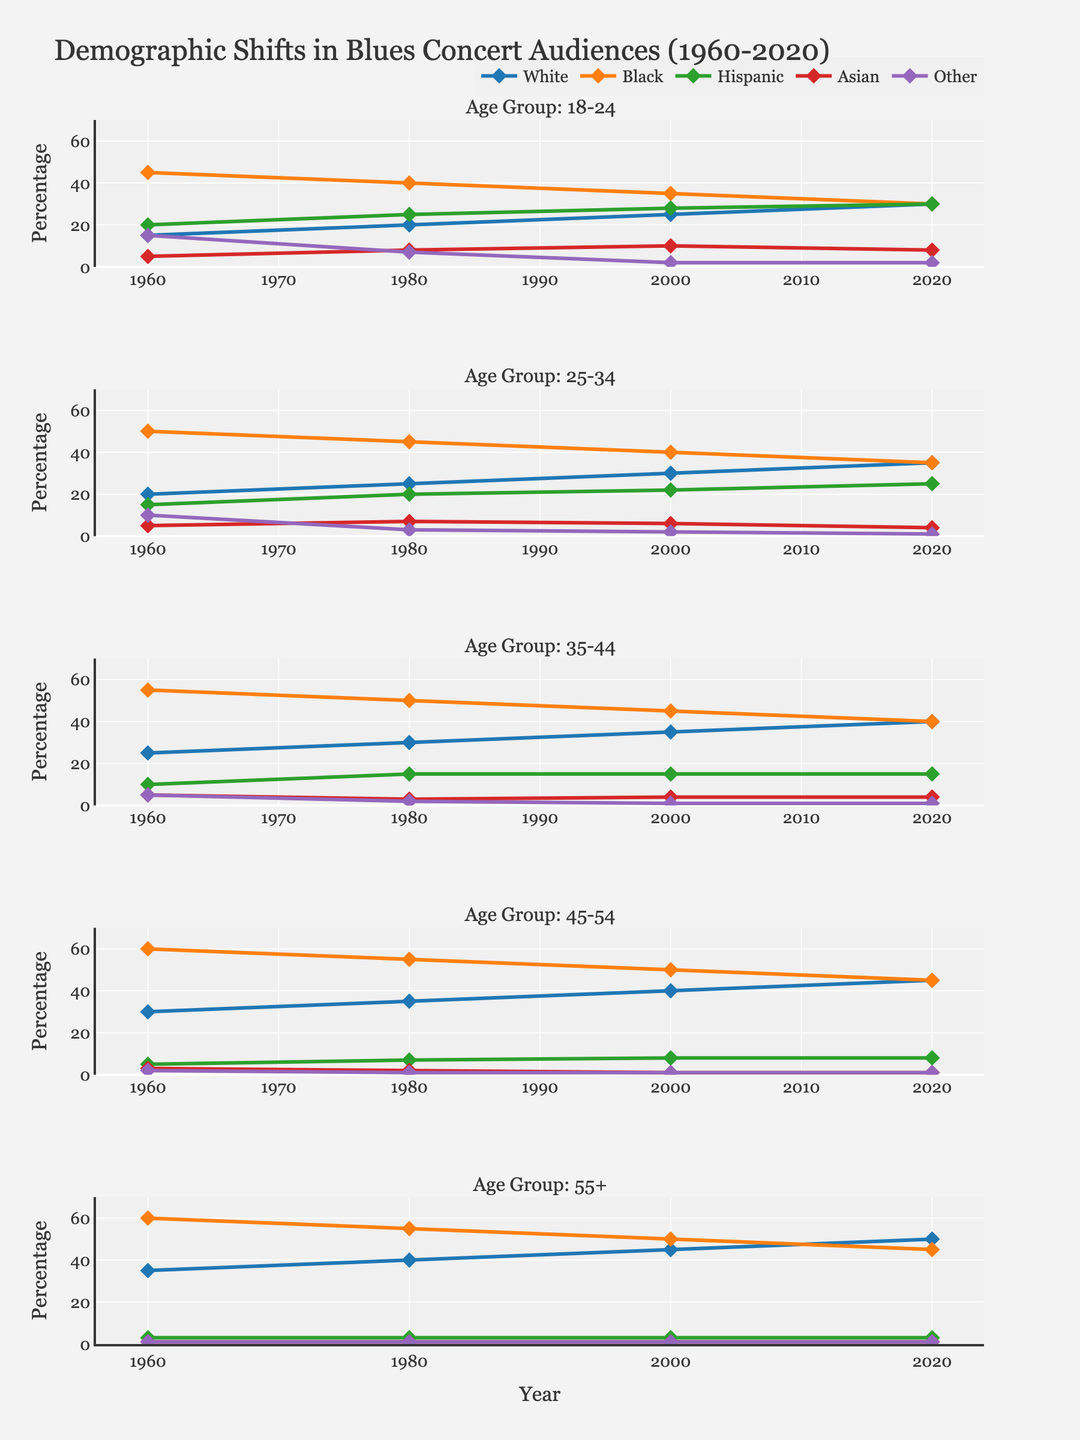How many different ethnic groups are represented in the figure? The figure shows five lines of different colors, one for each ethnic group: White, Black, Hispanic, Asian, and Other, indicated by the lines' colors and the legend.
Answer: Five What is the title of the figure? The title is located at the top of the figure and reads "Demographic Shifts in Blues Concert Audiences (1960-2020)".
Answer: Demographic Shifts in Blues Concert Audiences (1960-2020) Which ethnic group in the 35-44 age group saw the least change in percentage between 1960 and 2020? By examining the lines in the subplot for the 35-44 age group, the Asian group's line remains relatively flat, indicating minimal change from 1960 to 2020.
Answer: Asian In the 18-24 age group, which ethnicity had the highest percentage in 1980? In the subplot for the 18-24 age group, the line for Black attendees is highest on the y-axis in the year 1980.
Answer: Black How did the percentage of Hispanic attendees in the 25-34 age group change from 1960 to 2020? In the subplot for the 25-34 age group, the percentage of Hispanic attendees increased from 15% in 1960 to 25% in 2020.
Answer: Increased from 15% to 25% Which age group showed the most significant decrease in the percentage of Black attendees from 1960 to 2020? Comparing the subplots, the 55+ age group shows a notable decrease in the percentage of Black attendees from 60% in 1960 to 45% in 2020.
Answer: 55+ What is the general trend for the percentage of White attendees across all age groups from 1960 to 2020? All subplots show a gradual increase in the percentage of White attendees from 1960 to 2020.
Answer: Increasing Which age group had the highest percentage of Black attendees in 1960? In the subplot for each age group, the highest y-axis value for Black attendees in 1960 is around 60%, found in the 45-54 and 55+ age groups.
Answer: 45-54 and 55+ In which year did the 18-24 age group see an equal percentage of White and Hispanic attendees? In the 18-24 age group subplot, the lines for White and Hispanic attendees intersect in the year 2020, showing equal percentages.
Answer: 2020 